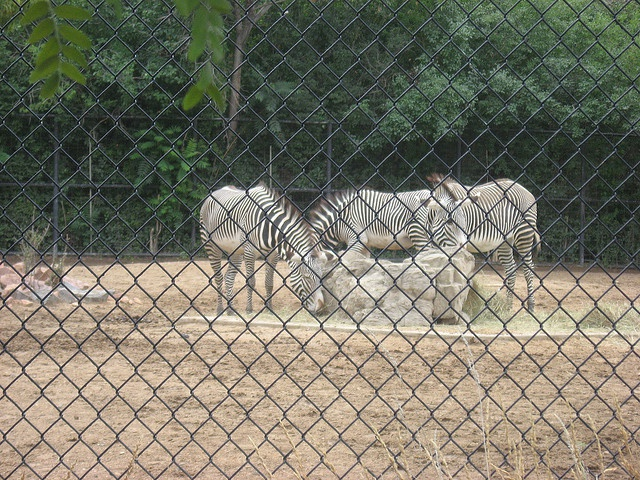Describe the objects in this image and their specific colors. I can see zebra in darkgreen, gray, darkgray, and lightgray tones, zebra in darkgreen, darkgray, gray, lightgray, and black tones, and zebra in darkgreen, gray, darkgray, lightgray, and black tones in this image. 